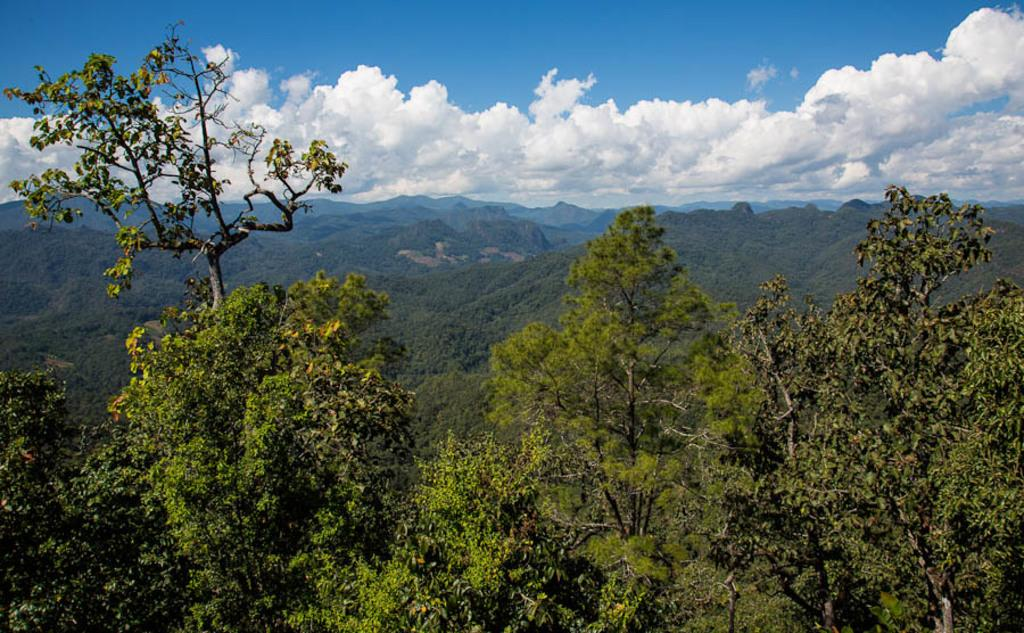What type of vegetation can be seen in the front of the image? There are trees in the front of the image. What type of natural formation can be seen in the background of the image? There are mountains in the background of the image. What type of vegetation can be seen in the background of the image? There are trees in the background of the image. What is the condition of the sky in the image? The sky is cloudy in the image. How many toys are scattered on the ground in the image? There are no toys present in the image. What type of currency is being used in the image? There is no reference to currency in the image. Is the father visible in the image? There is no person, including a father, present in the image. 